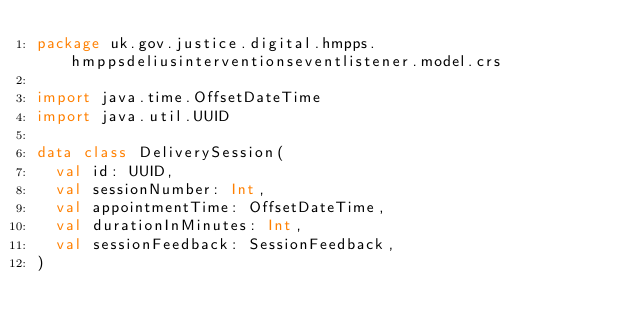<code> <loc_0><loc_0><loc_500><loc_500><_Kotlin_>package uk.gov.justice.digital.hmpps.hmppsdeliusinterventionseventlistener.model.crs

import java.time.OffsetDateTime
import java.util.UUID

data class DeliverySession(
  val id: UUID,
  val sessionNumber: Int,
  val appointmentTime: OffsetDateTime,
  val durationInMinutes: Int,
  val sessionFeedback: SessionFeedback,
)
</code> 